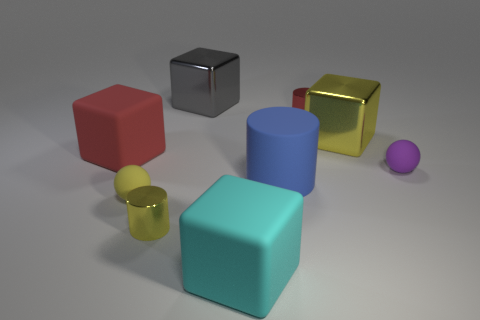What shape is the thing that is both behind the purple ball and on the right side of the tiny red metal object?
Make the answer very short. Cube. What number of other things are there of the same shape as the cyan object?
Keep it short and to the point. 3. There is a purple rubber object; is its shape the same as the small metal object on the left side of the big blue matte object?
Your response must be concise. No. What number of big blue rubber cylinders are on the left side of the large cyan object?
Your answer should be very brief. 0. Is there anything else that is made of the same material as the yellow block?
Provide a short and direct response. Yes. There is a large rubber object that is behind the large blue object; is it the same shape as the small red thing?
Your answer should be very brief. No. There is a tiny sphere on the left side of the matte cylinder; what color is it?
Keep it short and to the point. Yellow. There is a red object that is made of the same material as the large cyan thing; what shape is it?
Keep it short and to the point. Cube. Is there any other thing of the same color as the big cylinder?
Keep it short and to the point. No. Are there more cyan objects that are behind the yellow metallic cylinder than large blue matte objects that are on the right side of the tiny red metallic thing?
Offer a very short reply. No. 